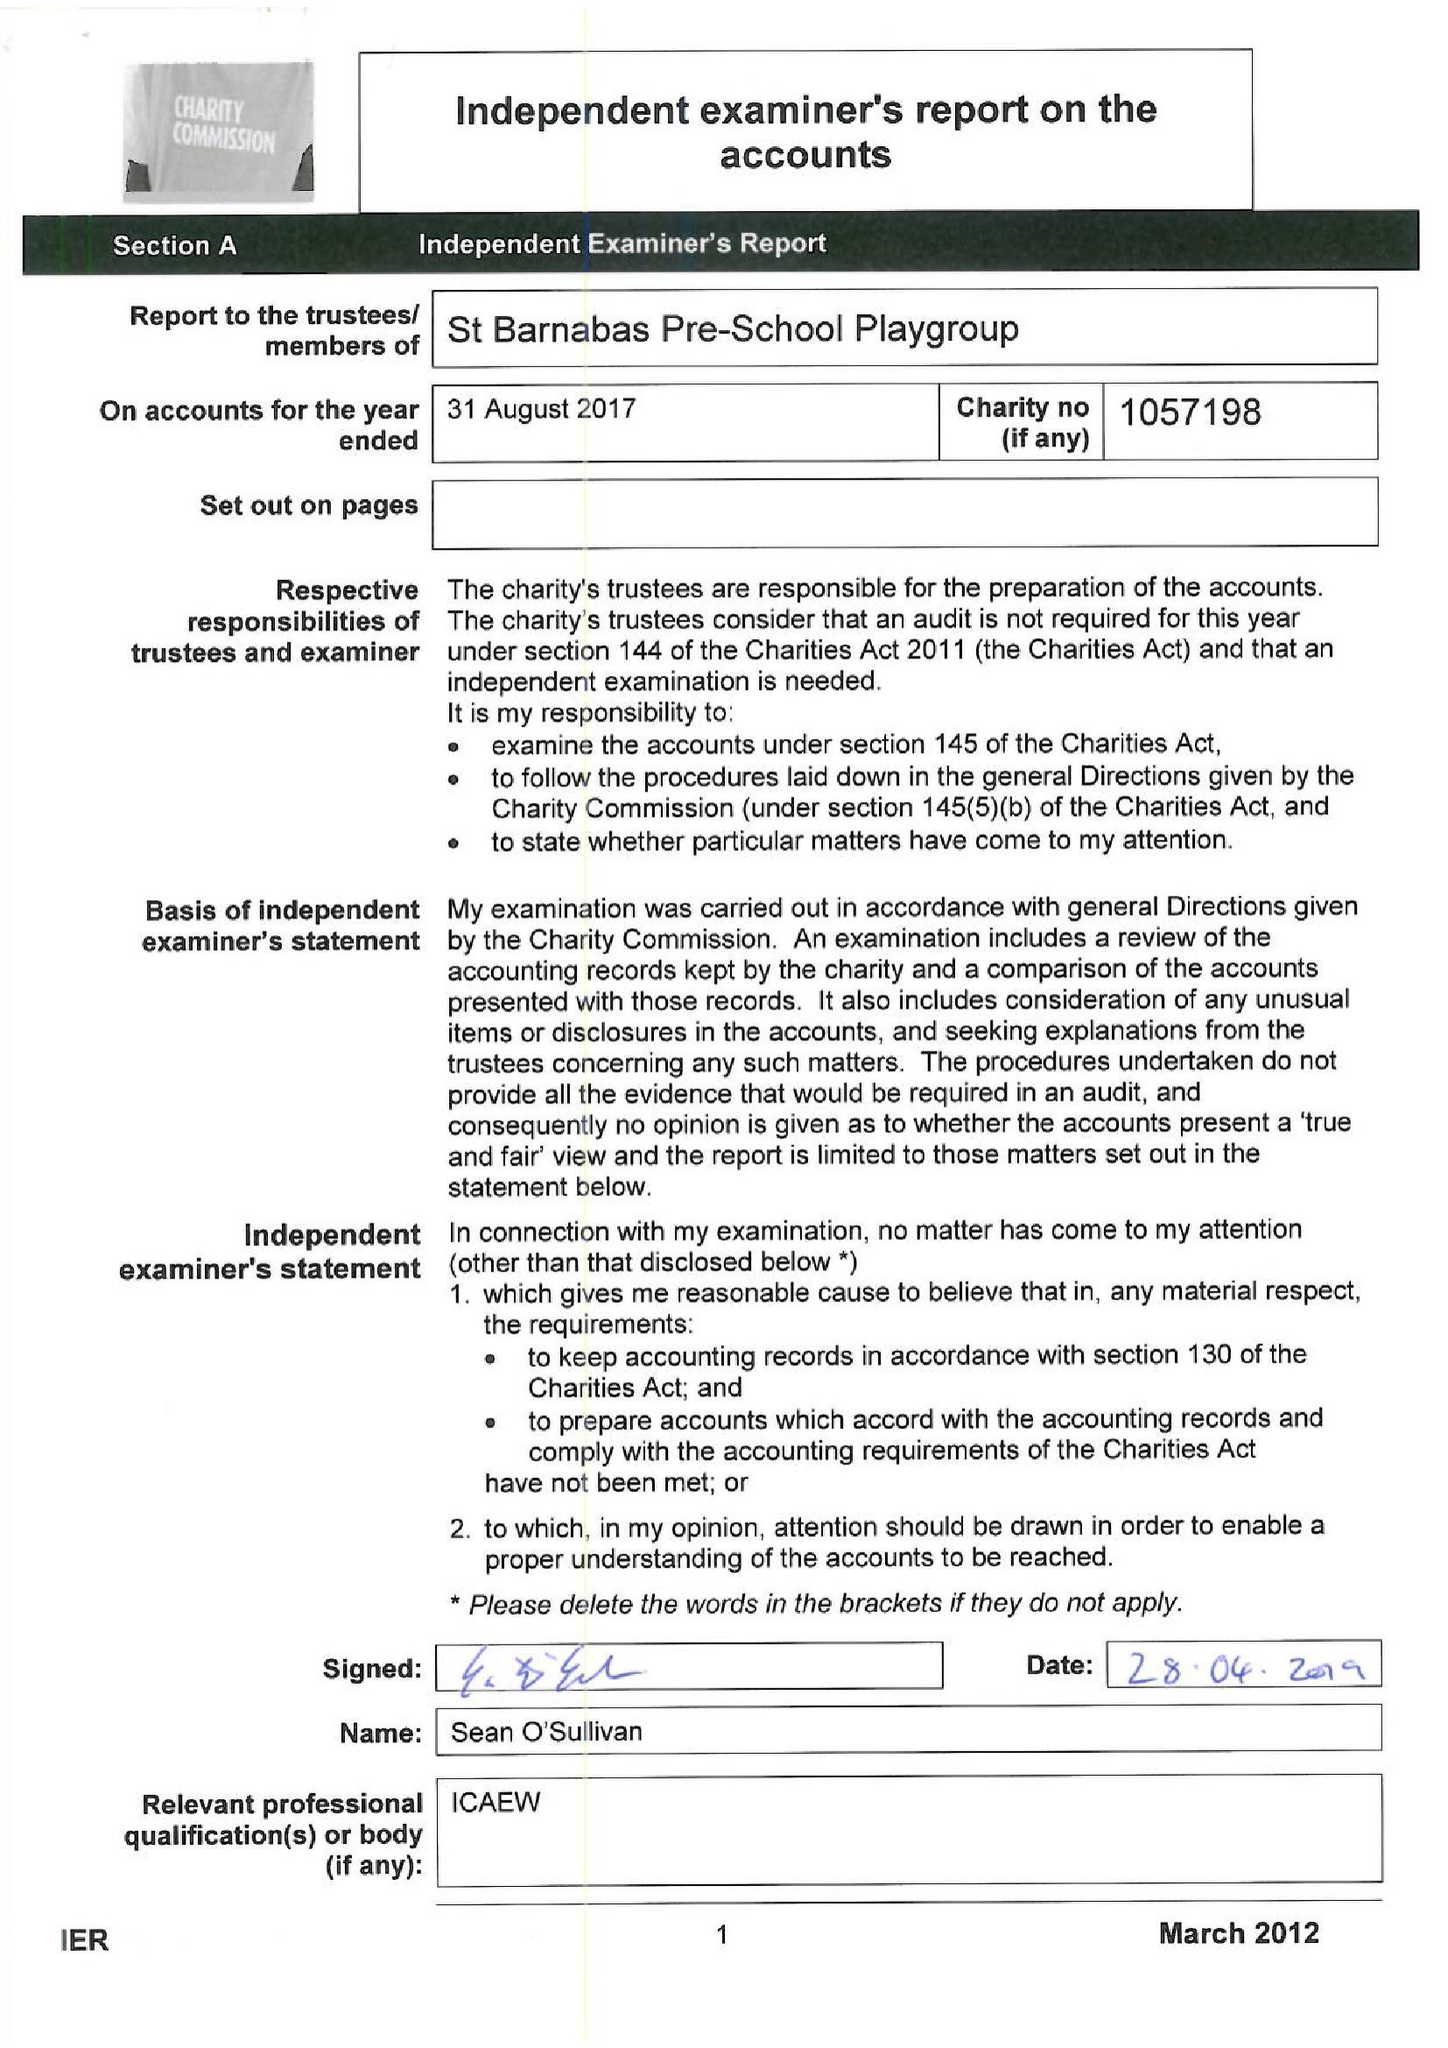What is the value for the address__post_town?
Answer the question using a single word or phrase. LONDON 